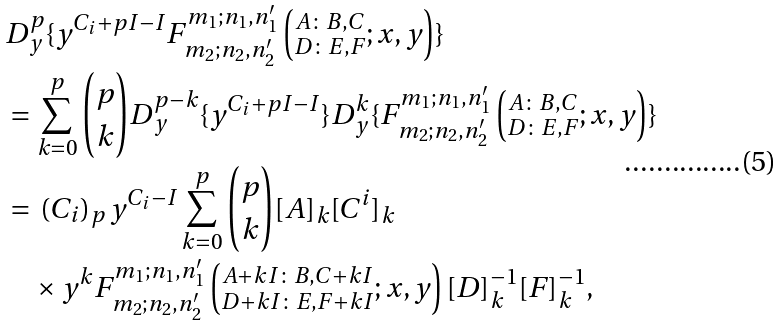Convert formula to latex. <formula><loc_0><loc_0><loc_500><loc_500>& D _ { y } ^ { p } \{ y ^ { C _ { i } + p I - I } F ^ { m _ { 1 } ; n _ { 1 } , n ^ { \prime } _ { 1 } } _ { m _ { 2 } ; n _ { 2 } , n ^ { \prime } _ { 2 } } \left ( ^ { A \colon B , C } _ { D \colon E , F } ; x , y \right ) \} \\ & = \sum _ { k = 0 } ^ { p } { p \choose k } D _ { y } ^ { p - k } \{ y ^ { C _ { i } + p I - I } \} D _ { y } ^ { k } \{ F ^ { m _ { 1 } ; n _ { 1 } , n ^ { \prime } _ { 1 } } _ { m _ { 2 } ; n _ { 2 } , n ^ { \prime } _ { 2 } } \left ( ^ { A \colon B , C } _ { D \colon E , F } ; x , y \right ) \} \\ & = \, ( C _ { i } ) _ { p } \, y ^ { C _ { i } - I } \sum _ { k = 0 } ^ { p } { p \choose k } { [ A ] _ { k } [ C ^ { i } ] _ { k } } \, \\ & \quad \times y ^ { k } F ^ { m _ { 1 } ; n _ { 1 } , n ^ { \prime } _ { 1 } } _ { m _ { 2 } ; n _ { 2 } , n ^ { \prime } _ { 2 } } \left ( ^ { A + k I \colon B , C + k I } _ { D + k I \colon E , F + k I } ; x , y \right ) [ D ] ^ { - 1 } _ { k } [ F ] ^ { - 1 } _ { k } ,</formula> 